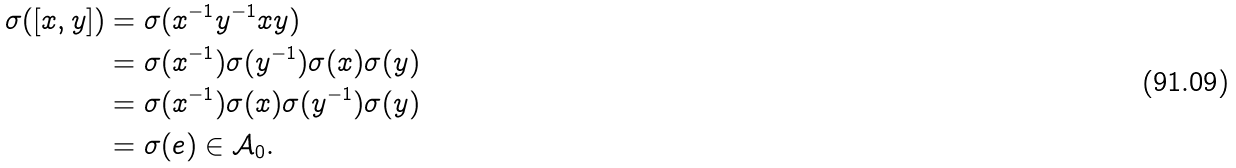<formula> <loc_0><loc_0><loc_500><loc_500>\sigma ( [ x , y ] ) & = \sigma ( x ^ { - 1 } y ^ { - 1 } x y ) \\ & = \sigma ( x ^ { - 1 } ) \sigma ( y ^ { - 1 } ) \sigma ( x ) \sigma ( y ) \\ & = \sigma ( x ^ { - 1 } ) \sigma ( x ) \sigma ( y ^ { - 1 } ) \sigma ( y ) \\ & = \sigma ( e ) \in \mathcal { A } _ { 0 } .</formula> 